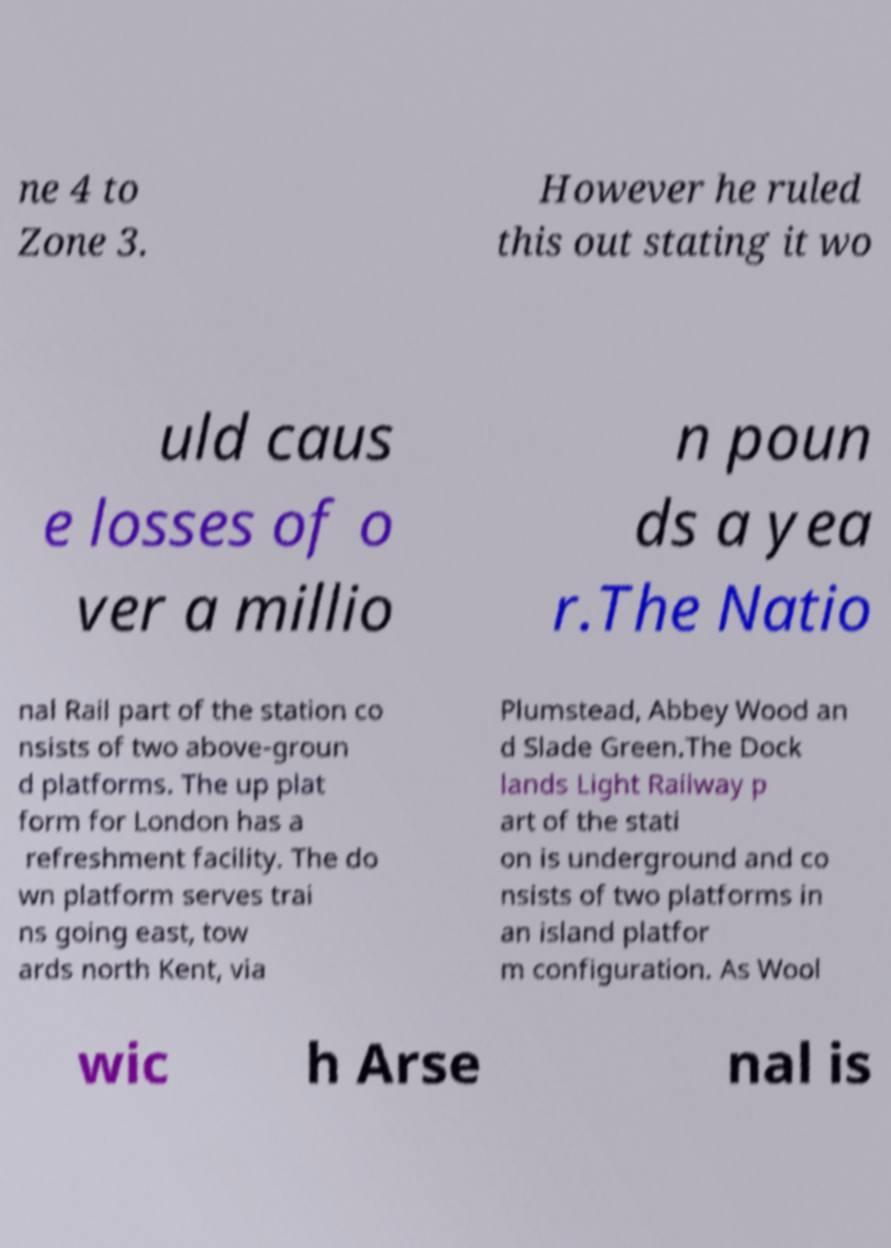Could you assist in decoding the text presented in this image and type it out clearly? ne 4 to Zone 3. However he ruled this out stating it wo uld caus e losses of o ver a millio n poun ds a yea r.The Natio nal Rail part of the station co nsists of two above-groun d platforms. The up plat form for London has a refreshment facility. The do wn platform serves trai ns going east, tow ards north Kent, via Plumstead, Abbey Wood an d Slade Green.The Dock lands Light Railway p art of the stati on is underground and co nsists of two platforms in an island platfor m configuration. As Wool wic h Arse nal is 